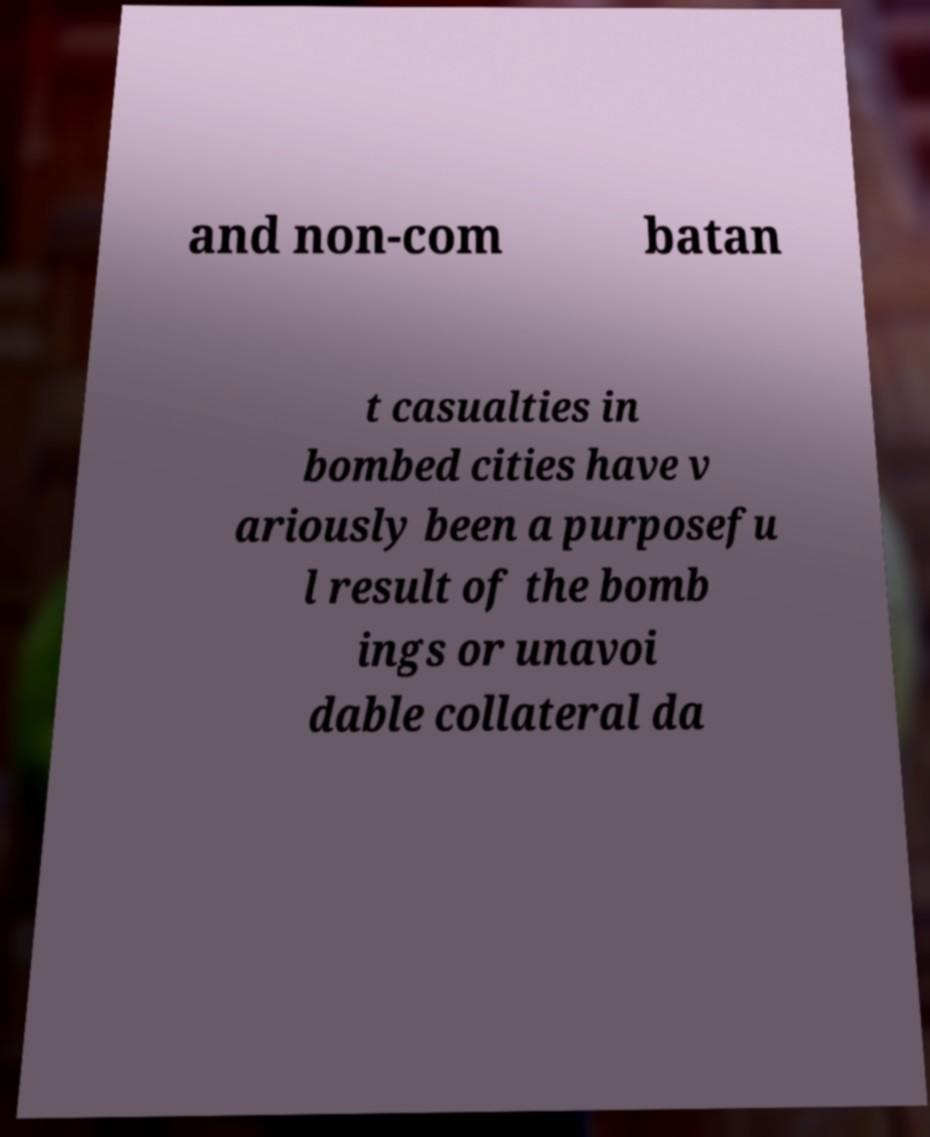Please read and relay the text visible in this image. What does it say? and non-com batan t casualties in bombed cities have v ariously been a purposefu l result of the bomb ings or unavoi dable collateral da 